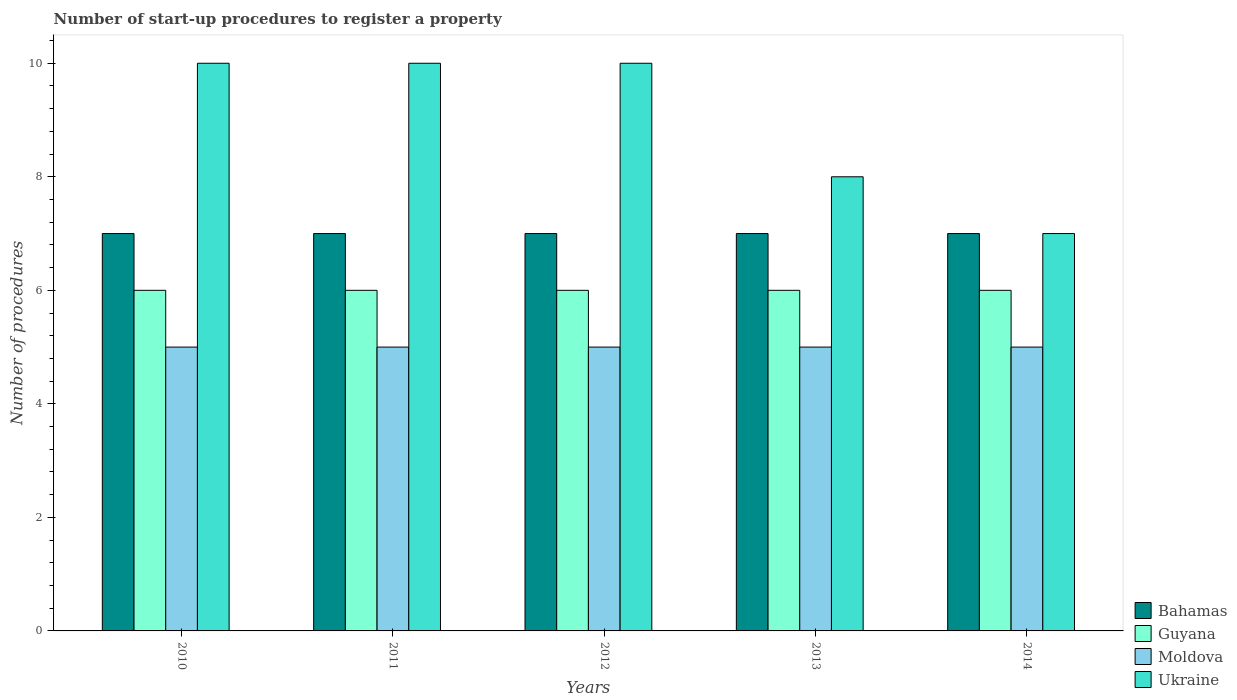How many groups of bars are there?
Make the answer very short. 5. Are the number of bars per tick equal to the number of legend labels?
Your response must be concise. Yes. Are the number of bars on each tick of the X-axis equal?
Ensure brevity in your answer.  Yes. How many bars are there on the 1st tick from the left?
Provide a short and direct response. 4. How many bars are there on the 1st tick from the right?
Keep it short and to the point. 4. In how many cases, is the number of bars for a given year not equal to the number of legend labels?
Keep it short and to the point. 0. What is the number of procedures required to register a property in Guyana in 2011?
Ensure brevity in your answer.  6. Across all years, what is the maximum number of procedures required to register a property in Ukraine?
Give a very brief answer. 10. Across all years, what is the minimum number of procedures required to register a property in Moldova?
Ensure brevity in your answer.  5. In which year was the number of procedures required to register a property in Bahamas maximum?
Offer a terse response. 2010. In which year was the number of procedures required to register a property in Bahamas minimum?
Your answer should be very brief. 2010. What is the total number of procedures required to register a property in Moldova in the graph?
Keep it short and to the point. 25. What is the difference between the number of procedures required to register a property in Guyana in 2011 and that in 2013?
Your answer should be very brief. 0. What is the difference between the number of procedures required to register a property in Ukraine in 2011 and the number of procedures required to register a property in Guyana in 2012?
Give a very brief answer. 4. What is the average number of procedures required to register a property in Guyana per year?
Your answer should be compact. 6. In how many years, is the number of procedures required to register a property in Moldova greater than 5.2?
Make the answer very short. 0. Is the difference between the number of procedures required to register a property in Guyana in 2012 and 2013 greater than the difference between the number of procedures required to register a property in Bahamas in 2012 and 2013?
Provide a succinct answer. No. What is the difference between the highest and the second highest number of procedures required to register a property in Ukraine?
Give a very brief answer. 0. What is the difference between the highest and the lowest number of procedures required to register a property in Bahamas?
Provide a succinct answer. 0. In how many years, is the number of procedures required to register a property in Bahamas greater than the average number of procedures required to register a property in Bahamas taken over all years?
Provide a short and direct response. 0. Is it the case that in every year, the sum of the number of procedures required to register a property in Guyana and number of procedures required to register a property in Ukraine is greater than the sum of number of procedures required to register a property in Moldova and number of procedures required to register a property in Bahamas?
Provide a succinct answer. No. What does the 1st bar from the left in 2014 represents?
Make the answer very short. Bahamas. What does the 2nd bar from the right in 2011 represents?
Your response must be concise. Moldova. What is the difference between two consecutive major ticks on the Y-axis?
Make the answer very short. 2. Does the graph contain grids?
Offer a terse response. No. Where does the legend appear in the graph?
Make the answer very short. Bottom right. What is the title of the graph?
Give a very brief answer. Number of start-up procedures to register a property. Does "Swaziland" appear as one of the legend labels in the graph?
Provide a short and direct response. No. What is the label or title of the Y-axis?
Provide a succinct answer. Number of procedures. What is the Number of procedures of Bahamas in 2010?
Give a very brief answer. 7. What is the Number of procedures of Guyana in 2010?
Provide a short and direct response. 6. What is the Number of procedures in Moldova in 2010?
Provide a short and direct response. 5. What is the Number of procedures in Ukraine in 2010?
Your response must be concise. 10. What is the Number of procedures in Moldova in 2011?
Offer a terse response. 5. What is the Number of procedures of Ukraine in 2011?
Give a very brief answer. 10. What is the Number of procedures of Bahamas in 2012?
Provide a succinct answer. 7. What is the Number of procedures of Ukraine in 2012?
Give a very brief answer. 10. What is the Number of procedures in Moldova in 2013?
Ensure brevity in your answer.  5. What is the Number of procedures of Ukraine in 2013?
Ensure brevity in your answer.  8. What is the Number of procedures in Bahamas in 2014?
Your answer should be very brief. 7. What is the Number of procedures of Guyana in 2014?
Offer a terse response. 6. What is the Number of procedures of Moldova in 2014?
Give a very brief answer. 5. What is the Number of procedures of Ukraine in 2014?
Offer a very short reply. 7. Across all years, what is the maximum Number of procedures in Bahamas?
Make the answer very short. 7. Across all years, what is the minimum Number of procedures of Bahamas?
Your answer should be very brief. 7. Across all years, what is the minimum Number of procedures in Ukraine?
Offer a very short reply. 7. What is the total Number of procedures in Guyana in the graph?
Offer a very short reply. 30. What is the total Number of procedures of Ukraine in the graph?
Keep it short and to the point. 45. What is the difference between the Number of procedures in Guyana in 2010 and that in 2011?
Offer a very short reply. 0. What is the difference between the Number of procedures in Moldova in 2010 and that in 2011?
Offer a terse response. 0. What is the difference between the Number of procedures of Guyana in 2010 and that in 2012?
Offer a very short reply. 0. What is the difference between the Number of procedures in Moldova in 2010 and that in 2012?
Offer a terse response. 0. What is the difference between the Number of procedures of Ukraine in 2010 and that in 2012?
Make the answer very short. 0. What is the difference between the Number of procedures of Moldova in 2010 and that in 2013?
Your answer should be very brief. 0. What is the difference between the Number of procedures in Ukraine in 2010 and that in 2013?
Make the answer very short. 2. What is the difference between the Number of procedures of Moldova in 2010 and that in 2014?
Give a very brief answer. 0. What is the difference between the Number of procedures in Guyana in 2011 and that in 2012?
Give a very brief answer. 0. What is the difference between the Number of procedures in Moldova in 2011 and that in 2012?
Offer a terse response. 0. What is the difference between the Number of procedures in Ukraine in 2011 and that in 2012?
Provide a short and direct response. 0. What is the difference between the Number of procedures in Moldova in 2011 and that in 2013?
Your answer should be compact. 0. What is the difference between the Number of procedures of Moldova in 2011 and that in 2014?
Make the answer very short. 0. What is the difference between the Number of procedures in Ukraine in 2011 and that in 2014?
Provide a short and direct response. 3. What is the difference between the Number of procedures of Bahamas in 2012 and that in 2013?
Offer a very short reply. 0. What is the difference between the Number of procedures of Guyana in 2012 and that in 2013?
Provide a succinct answer. 0. What is the difference between the Number of procedures of Moldova in 2012 and that in 2013?
Your response must be concise. 0. What is the difference between the Number of procedures of Bahamas in 2012 and that in 2014?
Your answer should be compact. 0. What is the difference between the Number of procedures of Guyana in 2012 and that in 2014?
Keep it short and to the point. 0. What is the difference between the Number of procedures in Ukraine in 2012 and that in 2014?
Your answer should be very brief. 3. What is the difference between the Number of procedures in Ukraine in 2013 and that in 2014?
Offer a terse response. 1. What is the difference between the Number of procedures of Bahamas in 2010 and the Number of procedures of Guyana in 2011?
Your answer should be compact. 1. What is the difference between the Number of procedures in Bahamas in 2010 and the Number of procedures in Moldova in 2011?
Your answer should be very brief. 2. What is the difference between the Number of procedures in Bahamas in 2010 and the Number of procedures in Ukraine in 2011?
Give a very brief answer. -3. What is the difference between the Number of procedures in Guyana in 2010 and the Number of procedures in Moldova in 2011?
Provide a short and direct response. 1. What is the difference between the Number of procedures of Guyana in 2010 and the Number of procedures of Ukraine in 2011?
Provide a succinct answer. -4. What is the difference between the Number of procedures of Bahamas in 2010 and the Number of procedures of Guyana in 2012?
Offer a terse response. 1. What is the difference between the Number of procedures of Bahamas in 2010 and the Number of procedures of Ukraine in 2012?
Keep it short and to the point. -3. What is the difference between the Number of procedures in Guyana in 2010 and the Number of procedures in Moldova in 2012?
Your answer should be compact. 1. What is the difference between the Number of procedures of Bahamas in 2010 and the Number of procedures of Guyana in 2013?
Your answer should be compact. 1. What is the difference between the Number of procedures in Bahamas in 2010 and the Number of procedures in Moldova in 2013?
Keep it short and to the point. 2. What is the difference between the Number of procedures of Bahamas in 2010 and the Number of procedures of Ukraine in 2013?
Give a very brief answer. -1. What is the difference between the Number of procedures in Moldova in 2010 and the Number of procedures in Ukraine in 2013?
Give a very brief answer. -3. What is the difference between the Number of procedures of Bahamas in 2010 and the Number of procedures of Moldova in 2014?
Your response must be concise. 2. What is the difference between the Number of procedures in Bahamas in 2010 and the Number of procedures in Ukraine in 2014?
Ensure brevity in your answer.  0. What is the difference between the Number of procedures in Guyana in 2010 and the Number of procedures in Ukraine in 2014?
Make the answer very short. -1. What is the difference between the Number of procedures in Bahamas in 2011 and the Number of procedures in Moldova in 2012?
Ensure brevity in your answer.  2. What is the difference between the Number of procedures of Bahamas in 2011 and the Number of procedures of Ukraine in 2012?
Offer a very short reply. -3. What is the difference between the Number of procedures in Guyana in 2011 and the Number of procedures in Ukraine in 2012?
Your answer should be very brief. -4. What is the difference between the Number of procedures of Moldova in 2011 and the Number of procedures of Ukraine in 2012?
Your response must be concise. -5. What is the difference between the Number of procedures of Bahamas in 2011 and the Number of procedures of Guyana in 2013?
Keep it short and to the point. 1. What is the difference between the Number of procedures of Guyana in 2011 and the Number of procedures of Ukraine in 2013?
Keep it short and to the point. -2. What is the difference between the Number of procedures of Bahamas in 2011 and the Number of procedures of Moldova in 2014?
Your answer should be very brief. 2. What is the difference between the Number of procedures in Guyana in 2011 and the Number of procedures in Moldova in 2014?
Your answer should be very brief. 1. What is the difference between the Number of procedures of Guyana in 2011 and the Number of procedures of Ukraine in 2014?
Offer a very short reply. -1. What is the difference between the Number of procedures in Moldova in 2011 and the Number of procedures in Ukraine in 2014?
Provide a succinct answer. -2. What is the difference between the Number of procedures in Bahamas in 2012 and the Number of procedures in Moldova in 2013?
Your response must be concise. 2. What is the difference between the Number of procedures in Bahamas in 2012 and the Number of procedures in Guyana in 2014?
Provide a short and direct response. 1. What is the difference between the Number of procedures in Bahamas in 2012 and the Number of procedures in Moldova in 2014?
Give a very brief answer. 2. What is the difference between the Number of procedures of Bahamas in 2012 and the Number of procedures of Ukraine in 2014?
Provide a succinct answer. 0. What is the difference between the Number of procedures in Guyana in 2012 and the Number of procedures in Ukraine in 2014?
Provide a succinct answer. -1. What is the difference between the Number of procedures in Bahamas in 2013 and the Number of procedures in Guyana in 2014?
Provide a short and direct response. 1. What is the difference between the Number of procedures in Bahamas in 2013 and the Number of procedures in Moldova in 2014?
Keep it short and to the point. 2. What is the difference between the Number of procedures in Guyana in 2013 and the Number of procedures in Moldova in 2014?
Make the answer very short. 1. What is the difference between the Number of procedures of Guyana in 2013 and the Number of procedures of Ukraine in 2014?
Offer a very short reply. -1. What is the difference between the Number of procedures of Moldova in 2013 and the Number of procedures of Ukraine in 2014?
Your answer should be very brief. -2. What is the average Number of procedures of Ukraine per year?
Offer a terse response. 9. In the year 2010, what is the difference between the Number of procedures in Bahamas and Number of procedures in Guyana?
Keep it short and to the point. 1. In the year 2010, what is the difference between the Number of procedures in Bahamas and Number of procedures in Ukraine?
Offer a terse response. -3. In the year 2010, what is the difference between the Number of procedures in Guyana and Number of procedures in Moldova?
Your response must be concise. 1. In the year 2011, what is the difference between the Number of procedures of Bahamas and Number of procedures of Moldova?
Offer a terse response. 2. In the year 2011, what is the difference between the Number of procedures of Bahamas and Number of procedures of Ukraine?
Your response must be concise. -3. In the year 2011, what is the difference between the Number of procedures of Guyana and Number of procedures of Moldova?
Keep it short and to the point. 1. In the year 2011, what is the difference between the Number of procedures in Guyana and Number of procedures in Ukraine?
Your answer should be compact. -4. In the year 2011, what is the difference between the Number of procedures in Moldova and Number of procedures in Ukraine?
Offer a very short reply. -5. In the year 2012, what is the difference between the Number of procedures in Bahamas and Number of procedures in Guyana?
Offer a terse response. 1. In the year 2012, what is the difference between the Number of procedures of Bahamas and Number of procedures of Ukraine?
Provide a short and direct response. -3. In the year 2012, what is the difference between the Number of procedures in Guyana and Number of procedures in Moldova?
Your answer should be very brief. 1. In the year 2013, what is the difference between the Number of procedures in Bahamas and Number of procedures in Ukraine?
Ensure brevity in your answer.  -1. In the year 2013, what is the difference between the Number of procedures in Guyana and Number of procedures in Moldova?
Offer a terse response. 1. In the year 2013, what is the difference between the Number of procedures of Guyana and Number of procedures of Ukraine?
Your answer should be very brief. -2. In the year 2014, what is the difference between the Number of procedures of Bahamas and Number of procedures of Guyana?
Offer a very short reply. 1. What is the ratio of the Number of procedures in Bahamas in 2010 to that in 2011?
Provide a short and direct response. 1. What is the ratio of the Number of procedures in Moldova in 2010 to that in 2011?
Provide a short and direct response. 1. What is the ratio of the Number of procedures of Ukraine in 2010 to that in 2012?
Offer a terse response. 1. What is the ratio of the Number of procedures in Ukraine in 2010 to that in 2013?
Ensure brevity in your answer.  1.25. What is the ratio of the Number of procedures in Bahamas in 2010 to that in 2014?
Make the answer very short. 1. What is the ratio of the Number of procedures of Guyana in 2010 to that in 2014?
Your answer should be compact. 1. What is the ratio of the Number of procedures in Ukraine in 2010 to that in 2014?
Offer a terse response. 1.43. What is the ratio of the Number of procedures of Ukraine in 2011 to that in 2012?
Give a very brief answer. 1. What is the ratio of the Number of procedures of Bahamas in 2011 to that in 2013?
Keep it short and to the point. 1. What is the ratio of the Number of procedures in Moldova in 2011 to that in 2013?
Ensure brevity in your answer.  1. What is the ratio of the Number of procedures of Moldova in 2011 to that in 2014?
Offer a terse response. 1. What is the ratio of the Number of procedures in Ukraine in 2011 to that in 2014?
Ensure brevity in your answer.  1.43. What is the ratio of the Number of procedures in Bahamas in 2012 to that in 2013?
Your answer should be compact. 1. What is the ratio of the Number of procedures of Moldova in 2012 to that in 2013?
Provide a short and direct response. 1. What is the ratio of the Number of procedures of Ukraine in 2012 to that in 2013?
Provide a short and direct response. 1.25. What is the ratio of the Number of procedures in Guyana in 2012 to that in 2014?
Your answer should be very brief. 1. What is the ratio of the Number of procedures of Moldova in 2012 to that in 2014?
Offer a terse response. 1. What is the ratio of the Number of procedures of Ukraine in 2012 to that in 2014?
Provide a short and direct response. 1.43. What is the ratio of the Number of procedures in Bahamas in 2013 to that in 2014?
Make the answer very short. 1. What is the ratio of the Number of procedures of Guyana in 2013 to that in 2014?
Provide a succinct answer. 1. What is the ratio of the Number of procedures in Moldova in 2013 to that in 2014?
Your answer should be compact. 1. What is the ratio of the Number of procedures in Ukraine in 2013 to that in 2014?
Provide a succinct answer. 1.14. What is the difference between the highest and the second highest Number of procedures in Guyana?
Offer a terse response. 0. What is the difference between the highest and the second highest Number of procedures in Moldova?
Keep it short and to the point. 0. What is the difference between the highest and the second highest Number of procedures in Ukraine?
Provide a succinct answer. 0. What is the difference between the highest and the lowest Number of procedures of Guyana?
Offer a terse response. 0. 